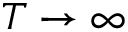<formula> <loc_0><loc_0><loc_500><loc_500>T \to \infty</formula> 